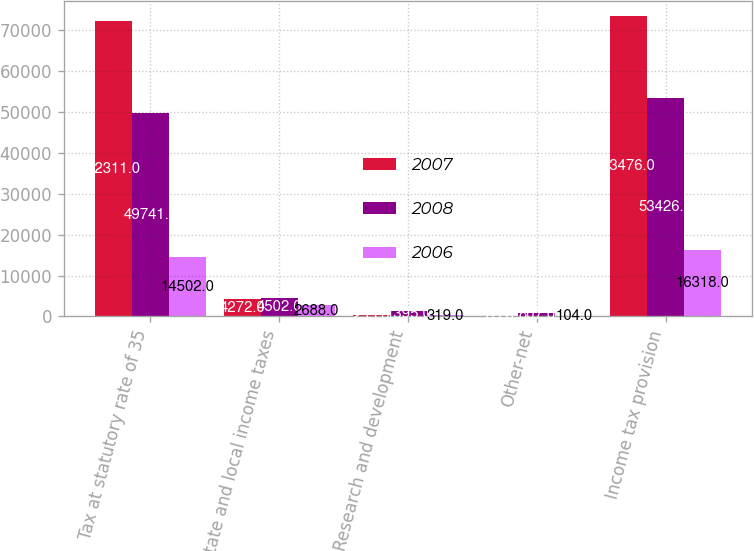Convert chart to OTSL. <chart><loc_0><loc_0><loc_500><loc_500><stacked_bar_chart><ecel><fcel>Tax at statutory rate of 35<fcel>State and local income taxes<fcel>Research and development<fcel>Other-net<fcel>Income tax provision<nl><fcel>2007<fcel>72311<fcel>4272<fcel>255<fcel>85<fcel>73476<nl><fcel>2008<fcel>49741<fcel>4502<fcel>1395<fcel>807<fcel>53426<nl><fcel>2006<fcel>14502<fcel>2688<fcel>319<fcel>104<fcel>16318<nl></chart> 